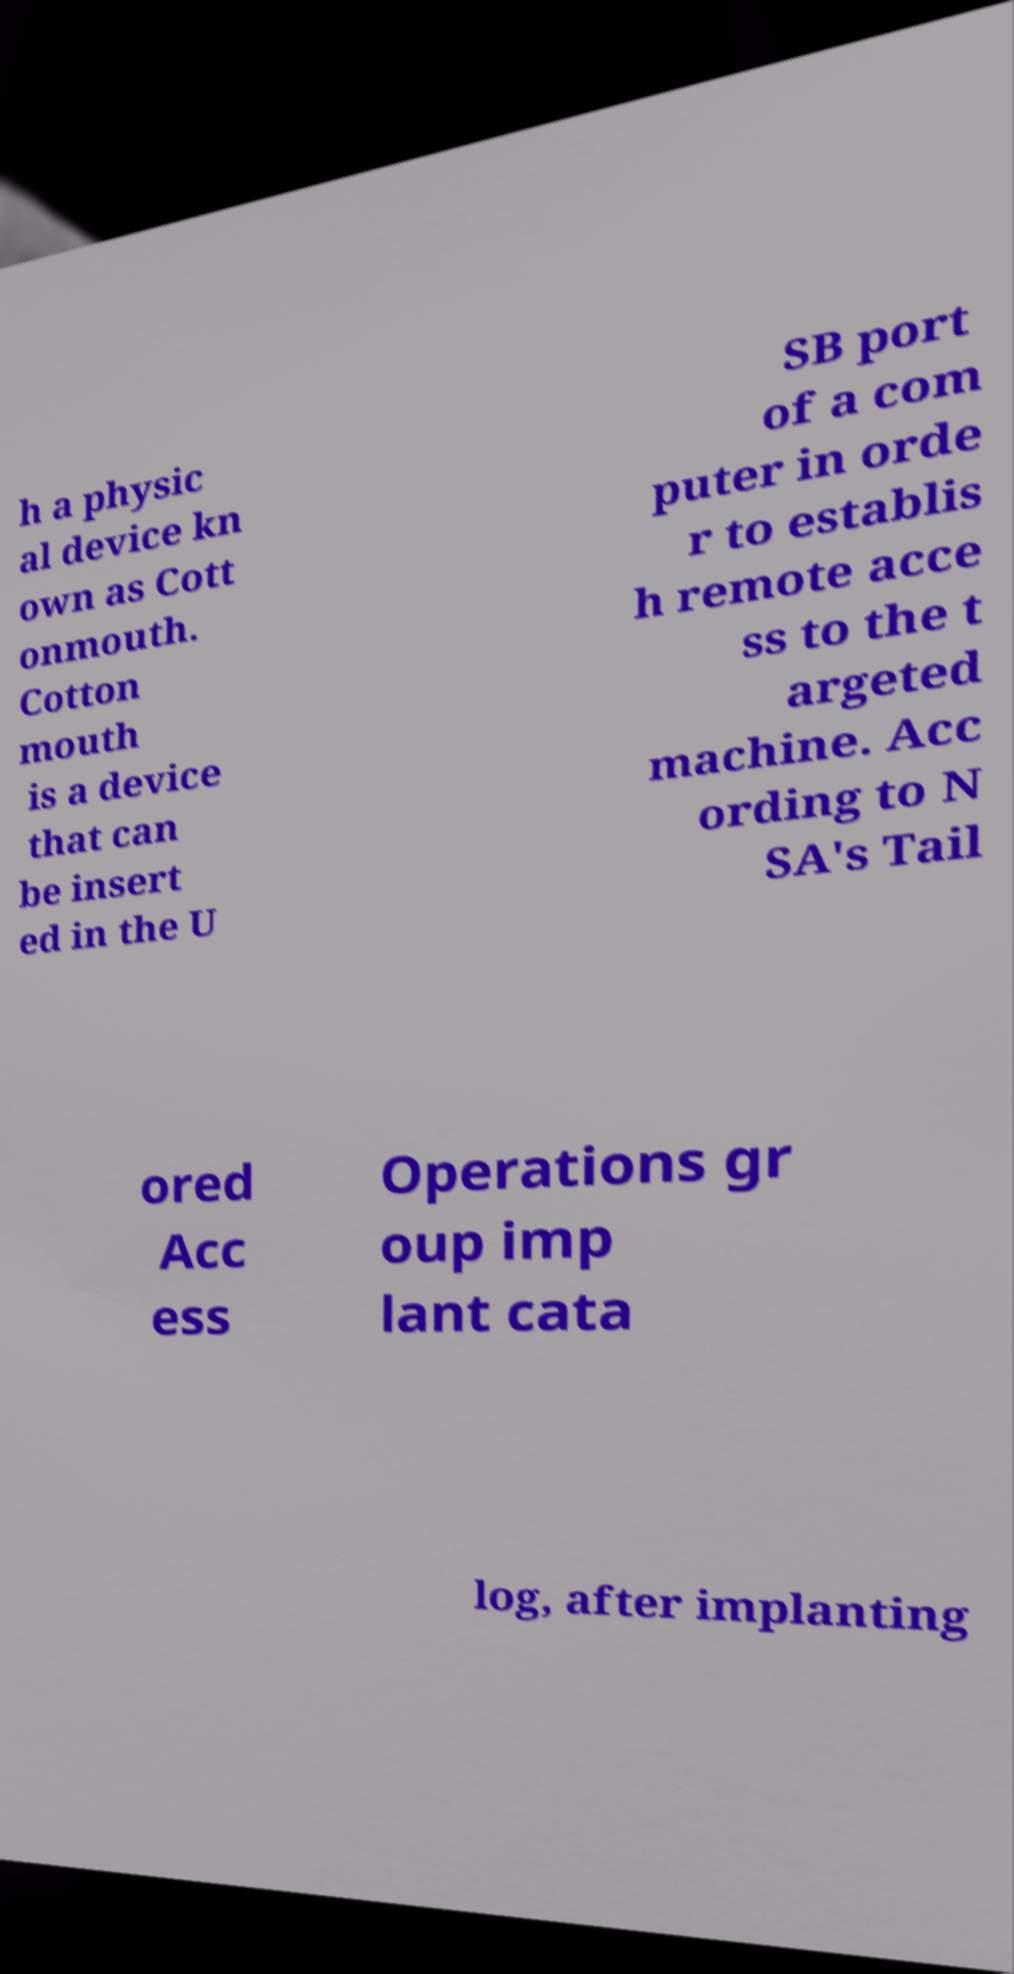Can you accurately transcribe the text from the provided image for me? h a physic al device kn own as Cott onmouth. Cotton mouth is a device that can be insert ed in the U SB port of a com puter in orde r to establis h remote acce ss to the t argeted machine. Acc ording to N SA's Tail ored Acc ess Operations gr oup imp lant cata log, after implanting 